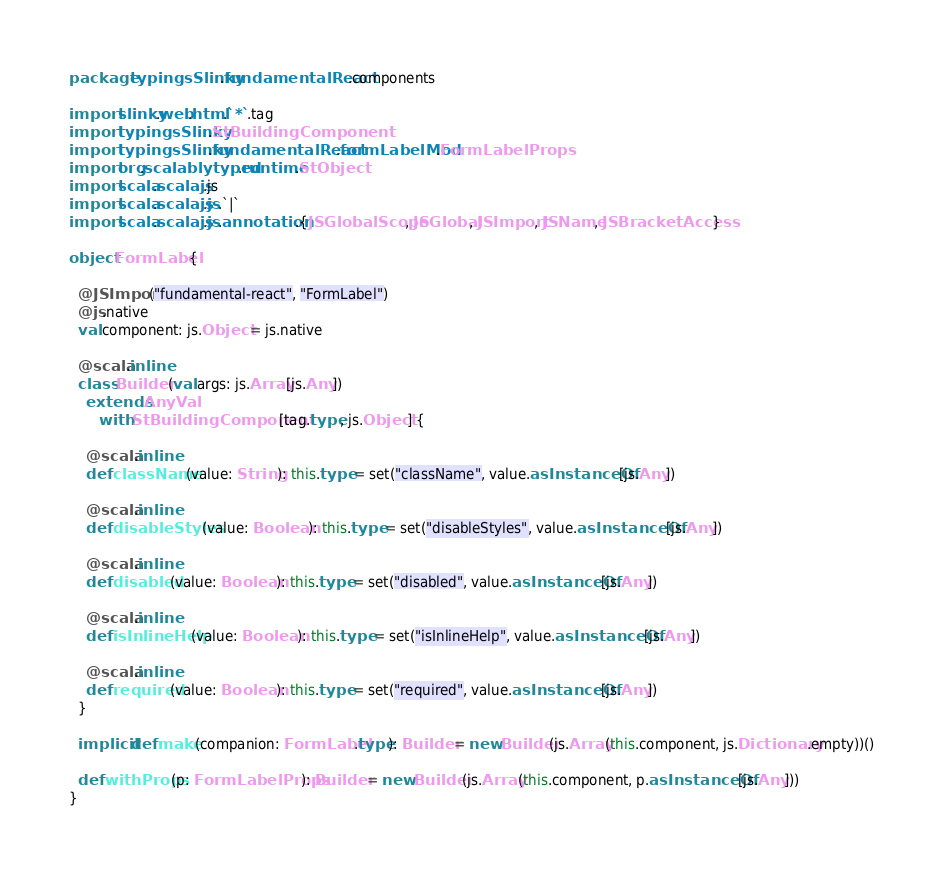<code> <loc_0><loc_0><loc_500><loc_500><_Scala_>package typingsSlinky.fundamentalReact.components

import slinky.web.html.`*`.tag
import typingsSlinky.StBuildingComponent
import typingsSlinky.fundamentalReact.formLabelMod.FormLabelProps
import org.scalablytyped.runtime.StObject
import scala.scalajs.js
import scala.scalajs.js.`|`
import scala.scalajs.js.annotation.{JSGlobalScope, JSGlobal, JSImport, JSName, JSBracketAccess}

object FormLabel {
  
  @JSImport("fundamental-react", "FormLabel")
  @js.native
  val component: js.Object = js.native
  
  @scala.inline
  class Builder (val args: js.Array[js.Any])
    extends AnyVal
       with StBuildingComponent[tag.type, js.Object] {
    
    @scala.inline
    def className(value: String): this.type = set("className", value.asInstanceOf[js.Any])
    
    @scala.inline
    def disableStyles(value: Boolean): this.type = set("disableStyles", value.asInstanceOf[js.Any])
    
    @scala.inline
    def disabled(value: Boolean): this.type = set("disabled", value.asInstanceOf[js.Any])
    
    @scala.inline
    def isInlineHelp(value: Boolean): this.type = set("isInlineHelp", value.asInstanceOf[js.Any])
    
    @scala.inline
    def required(value: Boolean): this.type = set("required", value.asInstanceOf[js.Any])
  }
  
  implicit def make(companion: FormLabel.type): Builder = new Builder(js.Array(this.component, js.Dictionary.empty))()
  
  def withProps(p: FormLabelProps): Builder = new Builder(js.Array(this.component, p.asInstanceOf[js.Any]))
}
</code> 